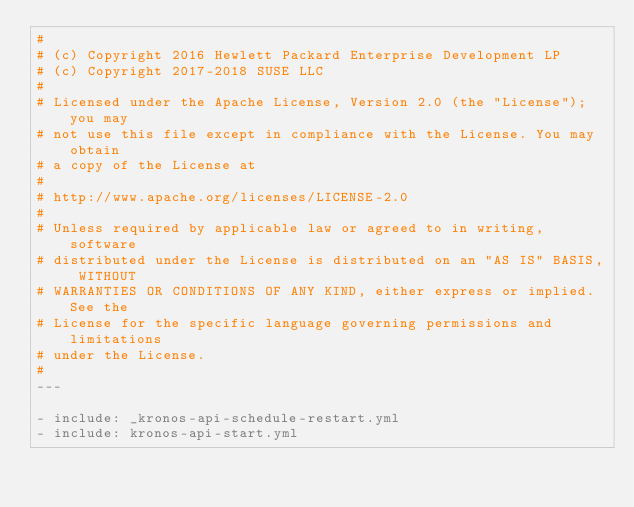Convert code to text. <code><loc_0><loc_0><loc_500><loc_500><_YAML_>#
# (c) Copyright 2016 Hewlett Packard Enterprise Development LP
# (c) Copyright 2017-2018 SUSE LLC
#
# Licensed under the Apache License, Version 2.0 (the "License"); you may
# not use this file except in compliance with the License. You may obtain
# a copy of the License at
#
# http://www.apache.org/licenses/LICENSE-2.0
#
# Unless required by applicable law or agreed to in writing, software
# distributed under the License is distributed on an "AS IS" BASIS, WITHOUT
# WARRANTIES OR CONDITIONS OF ANY KIND, either express or implied. See the
# License for the specific language governing permissions and limitations
# under the License.
#
---

- include: _kronos-api-schedule-restart.yml
- include: kronos-api-start.yml
</code> 